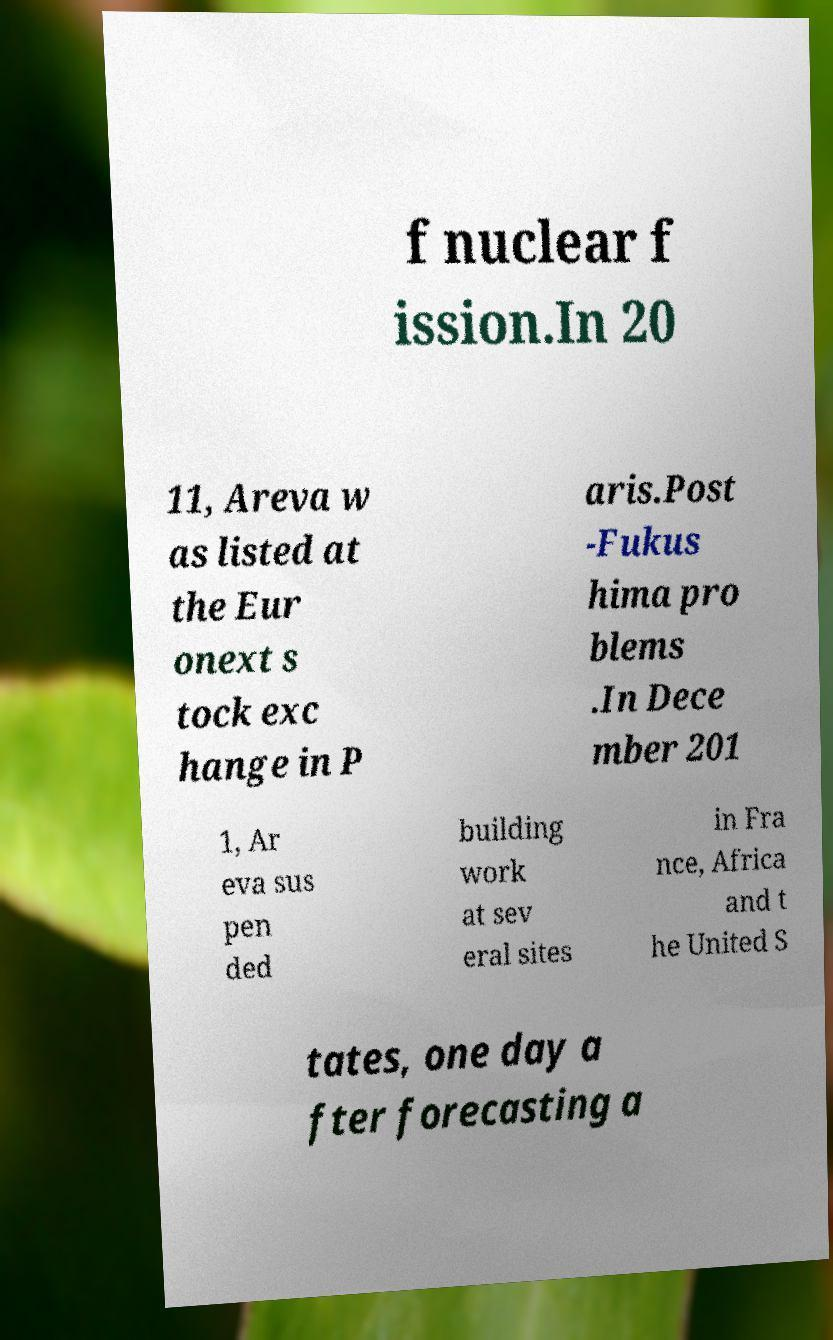What messages or text are displayed in this image? I need them in a readable, typed format. f nuclear f ission.In 20 11, Areva w as listed at the Eur onext s tock exc hange in P aris.Post -Fukus hima pro blems .In Dece mber 201 1, Ar eva sus pen ded building work at sev eral sites in Fra nce, Africa and t he United S tates, one day a fter forecasting a 